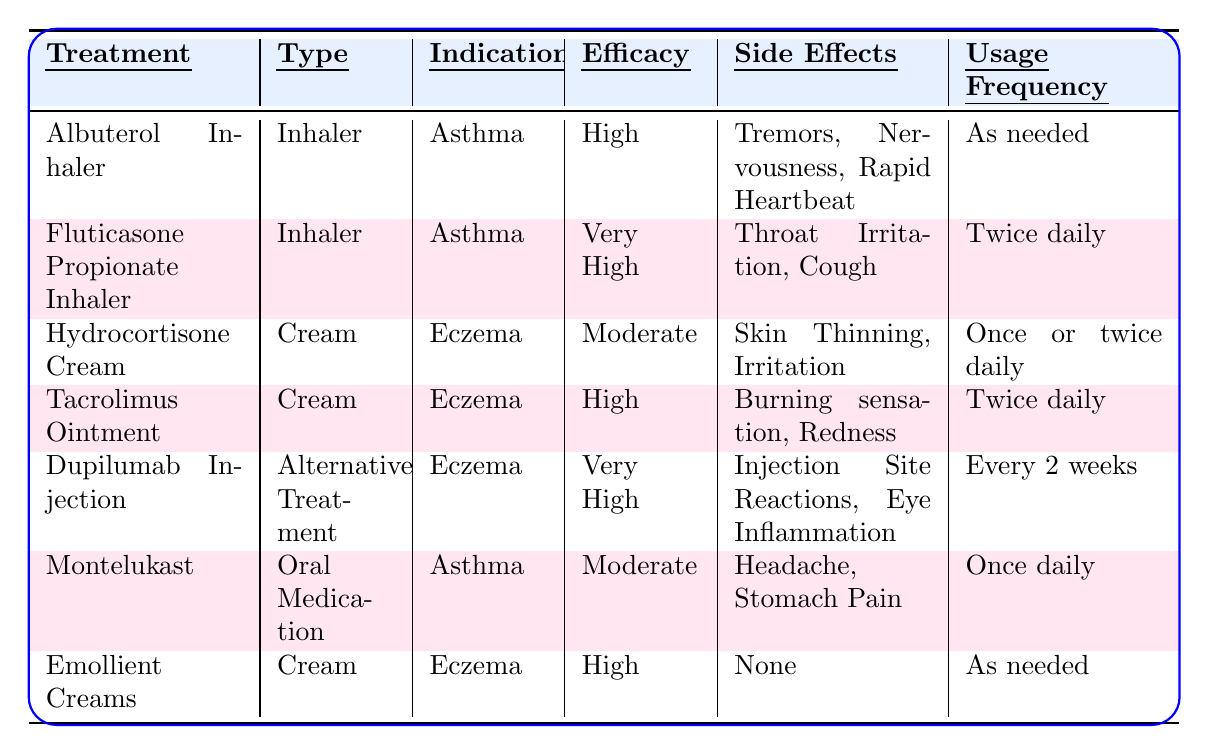What are the side effects of the Fluticasone Propionate Inhaler? The table indicates that the side effects of the Fluticasone Propionate Inhaler are Throat Irritation and Cough.
Answer: Throat Irritation, Cough Which treatment has the highest efficacy for eczema? According to the table, the Dupilumab Injection and Fluticasone Propionate Inhaler have "Very High" efficacy, while other treatments for eczema have "High" or "Moderate." Thus, the Dupilumab Injection has the highest efficacy for eczema.
Answer: Dupilumab Injection How many times a day should the Tacrolimus Ointment be used? The table specifies that the usage frequency for Tacrolimus Ointment is "Twice daily."
Answer: Twice daily Is the side effect "None" associated with any treatment? The table shows that the Emollient Creams have side effects listed as "None." Therefore, the answer is yes, it's associated with Emollient Creams.
Answer: Yes What is the difference in efficacy between the Albuterol Inhaler and Montelukast? The efficacy of the Albuterol Inhaler is "High" and Montelukast is "Moderate." The difference is 1 level; High is better than Moderate.
Answer: 1 level Which treatment has the highest usage frequency overall? The Fluticasone Propionate Inhaler and Tacrolimus Ointment have a fixed frequency, while the Dupilumab Injection’s schedule is longer. Since "As needed" is more flexible, the highest fixed frequency is for Fluticasone Propionate Inhaler and Tacrolimus Ointment at twice daily.
Answer: Twice daily Is there any inhaler that has a "Very High" efficiency? The table indicates that the Fluticasone Propionate Inhaler has a "Very High" efficacy for asthma. Thus, the answer is yes.
Answer: Yes How many treatments are used as needed? By examining the table, it shows that there are two treatments that require "As needed" usage: Albuterol Inhaler and Emollient Creams. Therefore, the total is 2 treatments.
Answer: 2 treatments If a person experiences burning sensation and redness, which treatment should they avoid? The Tacrolimus Ointment lists these as side effects. Therefore, a person experiencing these symptoms should avoid Tacrolimus Ointment.
Answer: Tacrolimus Ointment Which type of treatment has the most entries in the table? By counting, there are three creams, two inhalers, one oral medication, and one alternative treatment. Thus, creams have the most entries in the table with a total of three.
Answer: Cream What is the indication for the Emollient Creams? The table indicates that the Emollient Creams are used for Eczema.
Answer: Eczema 